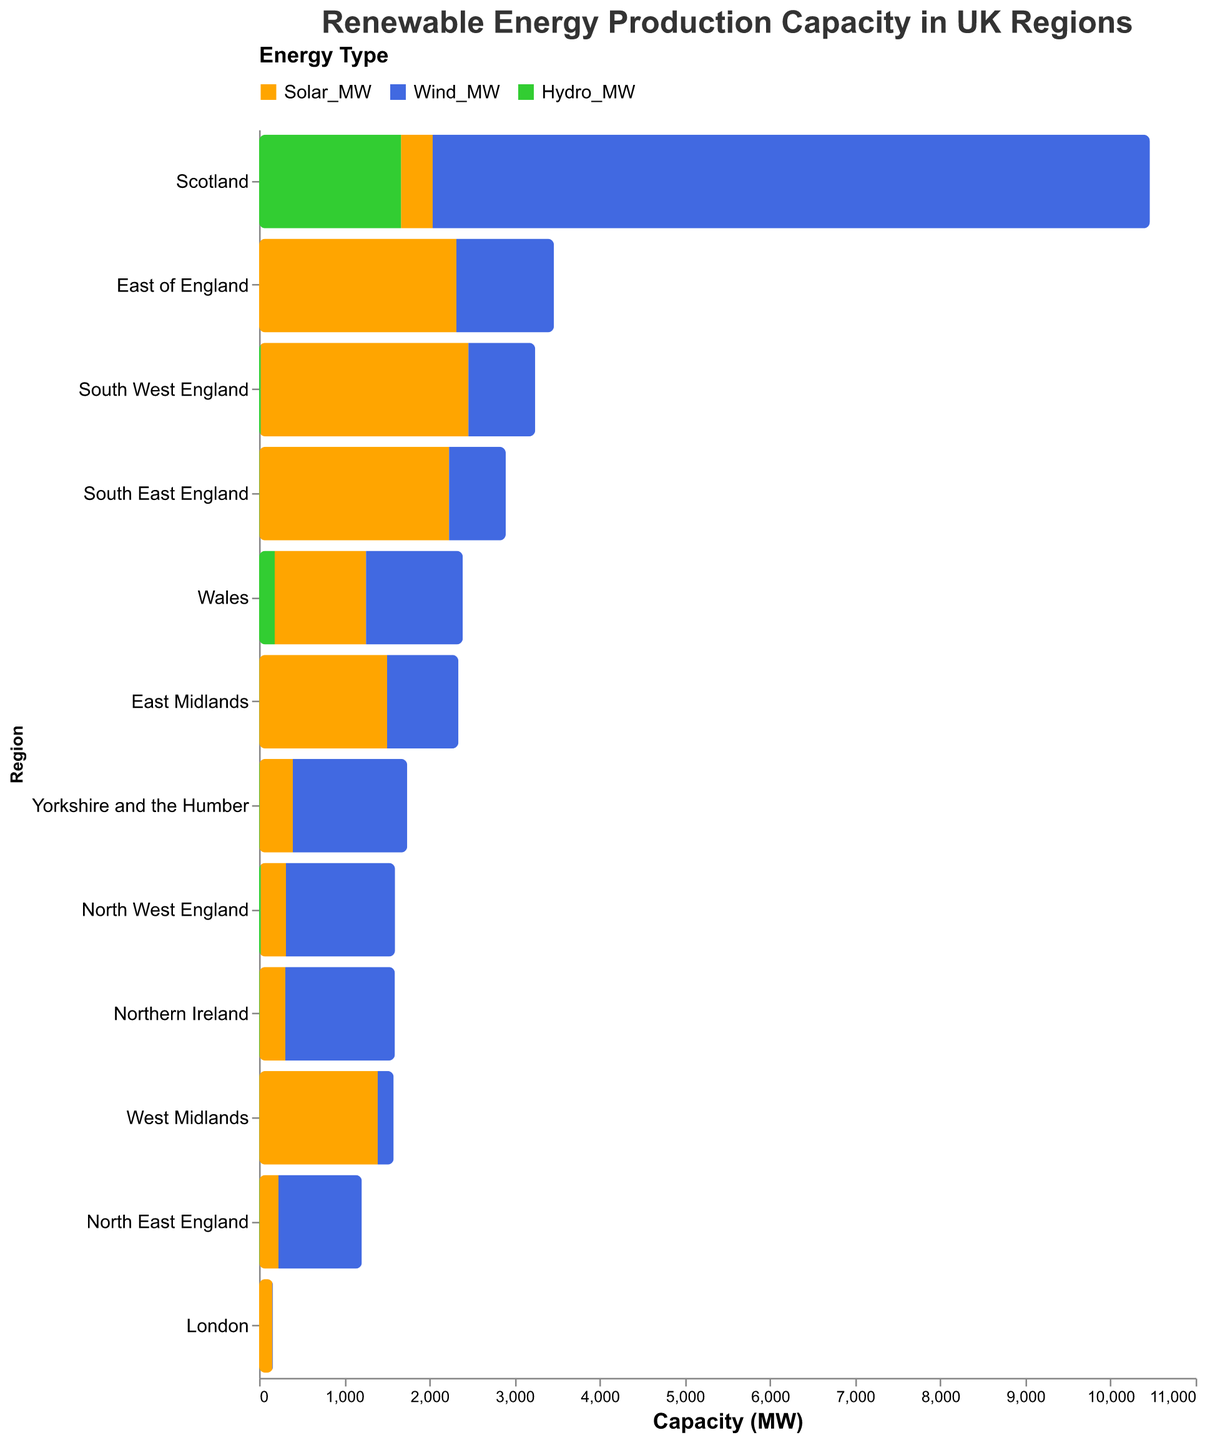Which region has the highest wind energy capacity? Examine the wind energy capacities for all regions in the plot. Scotland has the highest wind capacity at 8423 MW.
Answer: Scotland What is the total solar energy capacity for all regions combined? Sum up all the solar energy capacities: 372 + 1072 + 296 + 224 + 391 + 1502 + 1392 + 2317 + 156 + 2227 + 2440 + 303 = 12392 MW.
Answer: 12392 MW Which two regions have the lowest hydroelectric capacity? Review the hydroelectric capacities and identify the two regions with the smallest values. West Midlands and East of England both have the lowest at 1 MW and 0 MW respectively.
Answer: West Midlands and East of England Which region has more wind energy capacity: North West England or South West England? Compare the wind energy capacities of North West England (1282 MW) and South West England (785 MW). North West England has more.
Answer: North West England What is the average solar energy capacity of all regions? Calculate the average by summing up all solar energy capacities and dividing by the number of regions: (12392 MW / 12 regions) = approximately 1032.67 MW.
Answer: 1032.67 MW Which region in England has the highest solar energy capacity? Look at the solar energy capacities for regions specifically in England and find the highest value. South West England has the highest at 2440 MW.
Answer: South West England How does the hydroelectric capacity of Scotland compare to Wales? Compare the hydroelectric capacities of Scotland (1667 MW) and Wales (184 MW). Scotland has significantly higher hydroelectric capacity.
Answer: Scotland What is the combined capacity of renewable energy sources in the East Midlands? Add up the solar, wind, and hydro capacities for East Midlands: 1502 + 837 + 2 = 2341 MW.
Answer: 2341 MW What is the total wind energy capacity for all regions combined? Sum up all the wind energy capacities: 8423 + 1137 + 1282 + 980 + 1344 + 837 + 188 + 1146 + 8 + 666 + 785 + 1287 = 18083 MW.
Answer: 18083 MW Which region has the lowest renewable energy capacity when combining solar, wind, and hydro? Sum the capacities for solar, wind, and hydro for each region and identify the smallest value. London has the lowest total renewable capacity.
Answer: London 